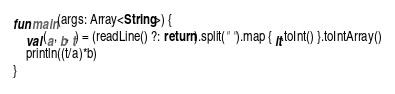<code> <loc_0><loc_0><loc_500><loc_500><_Kotlin_>fun main(args: Array<String>) {
	val (a, b, t) = (readLine() ?: return).split(" ").map { it.toInt() }.toIntArray()
	println((t/a)*b)
}</code> 